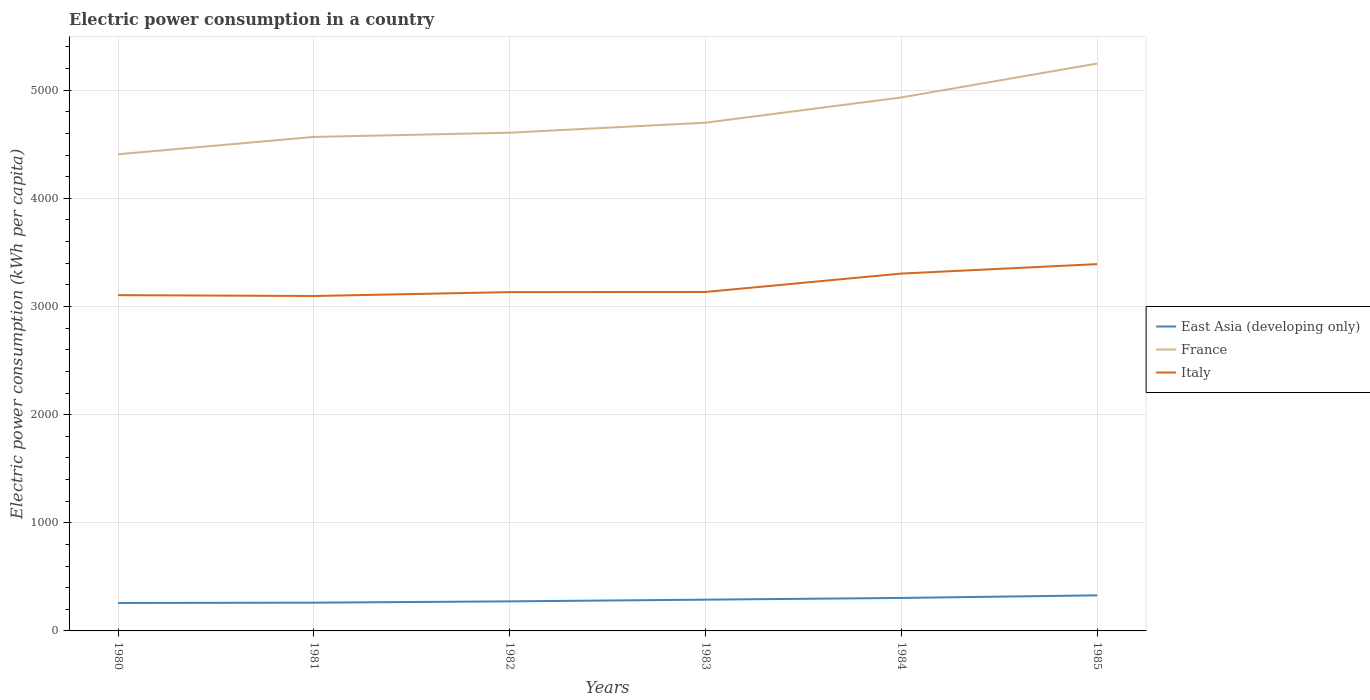Does the line corresponding to East Asia (developing only) intersect with the line corresponding to France?
Offer a very short reply. No. Is the number of lines equal to the number of legend labels?
Your answer should be very brief. Yes. Across all years, what is the maximum electric power consumption in in Italy?
Keep it short and to the point. 3096.93. In which year was the electric power consumption in in France maximum?
Your answer should be very brief. 1980. What is the total electric power consumption in in East Asia (developing only) in the graph?
Your answer should be very brief. -55.56. What is the difference between the highest and the second highest electric power consumption in in East Asia (developing only)?
Provide a succinct answer. 70.57. What is the difference between the highest and the lowest electric power consumption in in East Asia (developing only)?
Offer a terse response. 3. Is the electric power consumption in in East Asia (developing only) strictly greater than the electric power consumption in in France over the years?
Offer a very short reply. Yes. How many lines are there?
Your response must be concise. 3. Are the values on the major ticks of Y-axis written in scientific E-notation?
Offer a very short reply. No. Does the graph contain grids?
Keep it short and to the point. Yes. Where does the legend appear in the graph?
Keep it short and to the point. Center right. What is the title of the graph?
Make the answer very short. Electric power consumption in a country. Does "Uruguay" appear as one of the legend labels in the graph?
Make the answer very short. No. What is the label or title of the Y-axis?
Your answer should be very brief. Electric power consumption (kWh per capita). What is the Electric power consumption (kWh per capita) in East Asia (developing only) in 1980?
Ensure brevity in your answer.  258.4. What is the Electric power consumption (kWh per capita) of France in 1980?
Keep it short and to the point. 4407.65. What is the Electric power consumption (kWh per capita) in Italy in 1980?
Keep it short and to the point. 3104.85. What is the Electric power consumption (kWh per capita) of East Asia (developing only) in 1981?
Provide a short and direct response. 261.33. What is the Electric power consumption (kWh per capita) of France in 1981?
Keep it short and to the point. 4567.75. What is the Electric power consumption (kWh per capita) in Italy in 1981?
Your answer should be compact. 3096.93. What is the Electric power consumption (kWh per capita) of East Asia (developing only) in 1982?
Give a very brief answer. 273.41. What is the Electric power consumption (kWh per capita) of France in 1982?
Provide a short and direct response. 4606.91. What is the Electric power consumption (kWh per capita) in Italy in 1982?
Make the answer very short. 3132.77. What is the Electric power consumption (kWh per capita) in East Asia (developing only) in 1983?
Keep it short and to the point. 289.15. What is the Electric power consumption (kWh per capita) in France in 1983?
Your response must be concise. 4699.51. What is the Electric power consumption (kWh per capita) of Italy in 1983?
Your answer should be very brief. 3134.39. What is the Electric power consumption (kWh per capita) in East Asia (developing only) in 1984?
Offer a terse response. 305.06. What is the Electric power consumption (kWh per capita) of France in 1984?
Your response must be concise. 4933.01. What is the Electric power consumption (kWh per capita) in Italy in 1984?
Provide a succinct answer. 3304.33. What is the Electric power consumption (kWh per capita) in East Asia (developing only) in 1985?
Keep it short and to the point. 328.97. What is the Electric power consumption (kWh per capita) in France in 1985?
Your answer should be very brief. 5246.4. What is the Electric power consumption (kWh per capita) in Italy in 1985?
Give a very brief answer. 3391.67. Across all years, what is the maximum Electric power consumption (kWh per capita) of East Asia (developing only)?
Keep it short and to the point. 328.97. Across all years, what is the maximum Electric power consumption (kWh per capita) in France?
Ensure brevity in your answer.  5246.4. Across all years, what is the maximum Electric power consumption (kWh per capita) in Italy?
Give a very brief answer. 3391.67. Across all years, what is the minimum Electric power consumption (kWh per capita) of East Asia (developing only)?
Provide a short and direct response. 258.4. Across all years, what is the minimum Electric power consumption (kWh per capita) of France?
Your answer should be compact. 4407.65. Across all years, what is the minimum Electric power consumption (kWh per capita) of Italy?
Your answer should be compact. 3096.93. What is the total Electric power consumption (kWh per capita) of East Asia (developing only) in the graph?
Offer a very short reply. 1716.32. What is the total Electric power consumption (kWh per capita) of France in the graph?
Your response must be concise. 2.85e+04. What is the total Electric power consumption (kWh per capita) in Italy in the graph?
Provide a succinct answer. 1.92e+04. What is the difference between the Electric power consumption (kWh per capita) of East Asia (developing only) in 1980 and that in 1981?
Keep it short and to the point. -2.94. What is the difference between the Electric power consumption (kWh per capita) in France in 1980 and that in 1981?
Make the answer very short. -160.09. What is the difference between the Electric power consumption (kWh per capita) in Italy in 1980 and that in 1981?
Offer a terse response. 7.92. What is the difference between the Electric power consumption (kWh per capita) in East Asia (developing only) in 1980 and that in 1982?
Give a very brief answer. -15.01. What is the difference between the Electric power consumption (kWh per capita) of France in 1980 and that in 1982?
Make the answer very short. -199.25. What is the difference between the Electric power consumption (kWh per capita) in Italy in 1980 and that in 1982?
Ensure brevity in your answer.  -27.92. What is the difference between the Electric power consumption (kWh per capita) of East Asia (developing only) in 1980 and that in 1983?
Offer a very short reply. -30.75. What is the difference between the Electric power consumption (kWh per capita) of France in 1980 and that in 1983?
Offer a very short reply. -291.86. What is the difference between the Electric power consumption (kWh per capita) in Italy in 1980 and that in 1983?
Ensure brevity in your answer.  -29.54. What is the difference between the Electric power consumption (kWh per capita) of East Asia (developing only) in 1980 and that in 1984?
Keep it short and to the point. -46.66. What is the difference between the Electric power consumption (kWh per capita) of France in 1980 and that in 1984?
Your answer should be compact. -525.36. What is the difference between the Electric power consumption (kWh per capita) in Italy in 1980 and that in 1984?
Offer a terse response. -199.47. What is the difference between the Electric power consumption (kWh per capita) in East Asia (developing only) in 1980 and that in 1985?
Make the answer very short. -70.57. What is the difference between the Electric power consumption (kWh per capita) in France in 1980 and that in 1985?
Your answer should be very brief. -838.75. What is the difference between the Electric power consumption (kWh per capita) in Italy in 1980 and that in 1985?
Ensure brevity in your answer.  -286.81. What is the difference between the Electric power consumption (kWh per capita) of East Asia (developing only) in 1981 and that in 1982?
Your answer should be very brief. -12.08. What is the difference between the Electric power consumption (kWh per capita) of France in 1981 and that in 1982?
Offer a very short reply. -39.16. What is the difference between the Electric power consumption (kWh per capita) of Italy in 1981 and that in 1982?
Offer a very short reply. -35.84. What is the difference between the Electric power consumption (kWh per capita) of East Asia (developing only) in 1981 and that in 1983?
Make the answer very short. -27.82. What is the difference between the Electric power consumption (kWh per capita) of France in 1981 and that in 1983?
Provide a succinct answer. -131.76. What is the difference between the Electric power consumption (kWh per capita) in Italy in 1981 and that in 1983?
Provide a succinct answer. -37.46. What is the difference between the Electric power consumption (kWh per capita) in East Asia (developing only) in 1981 and that in 1984?
Your answer should be compact. -43.72. What is the difference between the Electric power consumption (kWh per capita) in France in 1981 and that in 1984?
Offer a very short reply. -365.26. What is the difference between the Electric power consumption (kWh per capita) in Italy in 1981 and that in 1984?
Give a very brief answer. -207.39. What is the difference between the Electric power consumption (kWh per capita) in East Asia (developing only) in 1981 and that in 1985?
Your answer should be very brief. -67.63. What is the difference between the Electric power consumption (kWh per capita) of France in 1981 and that in 1985?
Provide a succinct answer. -678.65. What is the difference between the Electric power consumption (kWh per capita) in Italy in 1981 and that in 1985?
Offer a terse response. -294.73. What is the difference between the Electric power consumption (kWh per capita) of East Asia (developing only) in 1982 and that in 1983?
Offer a very short reply. -15.74. What is the difference between the Electric power consumption (kWh per capita) in France in 1982 and that in 1983?
Ensure brevity in your answer.  -92.6. What is the difference between the Electric power consumption (kWh per capita) of Italy in 1982 and that in 1983?
Give a very brief answer. -1.62. What is the difference between the Electric power consumption (kWh per capita) in East Asia (developing only) in 1982 and that in 1984?
Give a very brief answer. -31.65. What is the difference between the Electric power consumption (kWh per capita) of France in 1982 and that in 1984?
Offer a terse response. -326.1. What is the difference between the Electric power consumption (kWh per capita) of Italy in 1982 and that in 1984?
Provide a short and direct response. -171.56. What is the difference between the Electric power consumption (kWh per capita) in East Asia (developing only) in 1982 and that in 1985?
Offer a very short reply. -55.56. What is the difference between the Electric power consumption (kWh per capita) of France in 1982 and that in 1985?
Your response must be concise. -639.49. What is the difference between the Electric power consumption (kWh per capita) in Italy in 1982 and that in 1985?
Offer a very short reply. -258.9. What is the difference between the Electric power consumption (kWh per capita) in East Asia (developing only) in 1983 and that in 1984?
Provide a succinct answer. -15.91. What is the difference between the Electric power consumption (kWh per capita) of France in 1983 and that in 1984?
Offer a terse response. -233.5. What is the difference between the Electric power consumption (kWh per capita) of Italy in 1983 and that in 1984?
Make the answer very short. -169.94. What is the difference between the Electric power consumption (kWh per capita) in East Asia (developing only) in 1983 and that in 1985?
Your response must be concise. -39.82. What is the difference between the Electric power consumption (kWh per capita) of France in 1983 and that in 1985?
Keep it short and to the point. -546.89. What is the difference between the Electric power consumption (kWh per capita) in Italy in 1983 and that in 1985?
Offer a terse response. -257.28. What is the difference between the Electric power consumption (kWh per capita) of East Asia (developing only) in 1984 and that in 1985?
Your answer should be very brief. -23.91. What is the difference between the Electric power consumption (kWh per capita) of France in 1984 and that in 1985?
Your answer should be compact. -313.39. What is the difference between the Electric power consumption (kWh per capita) of Italy in 1984 and that in 1985?
Your response must be concise. -87.34. What is the difference between the Electric power consumption (kWh per capita) of East Asia (developing only) in 1980 and the Electric power consumption (kWh per capita) of France in 1981?
Provide a succinct answer. -4309.35. What is the difference between the Electric power consumption (kWh per capita) in East Asia (developing only) in 1980 and the Electric power consumption (kWh per capita) in Italy in 1981?
Your answer should be compact. -2838.54. What is the difference between the Electric power consumption (kWh per capita) of France in 1980 and the Electric power consumption (kWh per capita) of Italy in 1981?
Offer a terse response. 1310.72. What is the difference between the Electric power consumption (kWh per capita) in East Asia (developing only) in 1980 and the Electric power consumption (kWh per capita) in France in 1982?
Ensure brevity in your answer.  -4348.51. What is the difference between the Electric power consumption (kWh per capita) of East Asia (developing only) in 1980 and the Electric power consumption (kWh per capita) of Italy in 1982?
Your answer should be compact. -2874.37. What is the difference between the Electric power consumption (kWh per capita) in France in 1980 and the Electric power consumption (kWh per capita) in Italy in 1982?
Give a very brief answer. 1274.88. What is the difference between the Electric power consumption (kWh per capita) of East Asia (developing only) in 1980 and the Electric power consumption (kWh per capita) of France in 1983?
Your answer should be very brief. -4441.11. What is the difference between the Electric power consumption (kWh per capita) in East Asia (developing only) in 1980 and the Electric power consumption (kWh per capita) in Italy in 1983?
Keep it short and to the point. -2875.99. What is the difference between the Electric power consumption (kWh per capita) in France in 1980 and the Electric power consumption (kWh per capita) in Italy in 1983?
Your answer should be compact. 1273.26. What is the difference between the Electric power consumption (kWh per capita) in East Asia (developing only) in 1980 and the Electric power consumption (kWh per capita) in France in 1984?
Provide a succinct answer. -4674.61. What is the difference between the Electric power consumption (kWh per capita) of East Asia (developing only) in 1980 and the Electric power consumption (kWh per capita) of Italy in 1984?
Ensure brevity in your answer.  -3045.93. What is the difference between the Electric power consumption (kWh per capita) of France in 1980 and the Electric power consumption (kWh per capita) of Italy in 1984?
Your response must be concise. 1103.33. What is the difference between the Electric power consumption (kWh per capita) of East Asia (developing only) in 1980 and the Electric power consumption (kWh per capita) of France in 1985?
Make the answer very short. -4988. What is the difference between the Electric power consumption (kWh per capita) of East Asia (developing only) in 1980 and the Electric power consumption (kWh per capita) of Italy in 1985?
Your answer should be compact. -3133.27. What is the difference between the Electric power consumption (kWh per capita) of France in 1980 and the Electric power consumption (kWh per capita) of Italy in 1985?
Offer a terse response. 1015.98. What is the difference between the Electric power consumption (kWh per capita) of East Asia (developing only) in 1981 and the Electric power consumption (kWh per capita) of France in 1982?
Your answer should be compact. -4345.57. What is the difference between the Electric power consumption (kWh per capita) in East Asia (developing only) in 1981 and the Electric power consumption (kWh per capita) in Italy in 1982?
Provide a short and direct response. -2871.44. What is the difference between the Electric power consumption (kWh per capita) in France in 1981 and the Electric power consumption (kWh per capita) in Italy in 1982?
Offer a very short reply. 1434.98. What is the difference between the Electric power consumption (kWh per capita) in East Asia (developing only) in 1981 and the Electric power consumption (kWh per capita) in France in 1983?
Keep it short and to the point. -4438.18. What is the difference between the Electric power consumption (kWh per capita) in East Asia (developing only) in 1981 and the Electric power consumption (kWh per capita) in Italy in 1983?
Your answer should be compact. -2873.06. What is the difference between the Electric power consumption (kWh per capita) of France in 1981 and the Electric power consumption (kWh per capita) of Italy in 1983?
Keep it short and to the point. 1433.36. What is the difference between the Electric power consumption (kWh per capita) of East Asia (developing only) in 1981 and the Electric power consumption (kWh per capita) of France in 1984?
Provide a succinct answer. -4671.68. What is the difference between the Electric power consumption (kWh per capita) of East Asia (developing only) in 1981 and the Electric power consumption (kWh per capita) of Italy in 1984?
Ensure brevity in your answer.  -3042.99. What is the difference between the Electric power consumption (kWh per capita) in France in 1981 and the Electric power consumption (kWh per capita) in Italy in 1984?
Offer a terse response. 1263.42. What is the difference between the Electric power consumption (kWh per capita) in East Asia (developing only) in 1981 and the Electric power consumption (kWh per capita) in France in 1985?
Offer a very short reply. -4985.07. What is the difference between the Electric power consumption (kWh per capita) in East Asia (developing only) in 1981 and the Electric power consumption (kWh per capita) in Italy in 1985?
Provide a short and direct response. -3130.34. What is the difference between the Electric power consumption (kWh per capita) of France in 1981 and the Electric power consumption (kWh per capita) of Italy in 1985?
Provide a short and direct response. 1176.08. What is the difference between the Electric power consumption (kWh per capita) of East Asia (developing only) in 1982 and the Electric power consumption (kWh per capita) of France in 1983?
Make the answer very short. -4426.1. What is the difference between the Electric power consumption (kWh per capita) in East Asia (developing only) in 1982 and the Electric power consumption (kWh per capita) in Italy in 1983?
Offer a terse response. -2860.98. What is the difference between the Electric power consumption (kWh per capita) in France in 1982 and the Electric power consumption (kWh per capita) in Italy in 1983?
Your response must be concise. 1472.52. What is the difference between the Electric power consumption (kWh per capita) in East Asia (developing only) in 1982 and the Electric power consumption (kWh per capita) in France in 1984?
Keep it short and to the point. -4659.6. What is the difference between the Electric power consumption (kWh per capita) of East Asia (developing only) in 1982 and the Electric power consumption (kWh per capita) of Italy in 1984?
Your answer should be very brief. -3030.92. What is the difference between the Electric power consumption (kWh per capita) in France in 1982 and the Electric power consumption (kWh per capita) in Italy in 1984?
Give a very brief answer. 1302.58. What is the difference between the Electric power consumption (kWh per capita) in East Asia (developing only) in 1982 and the Electric power consumption (kWh per capita) in France in 1985?
Offer a terse response. -4972.99. What is the difference between the Electric power consumption (kWh per capita) of East Asia (developing only) in 1982 and the Electric power consumption (kWh per capita) of Italy in 1985?
Ensure brevity in your answer.  -3118.26. What is the difference between the Electric power consumption (kWh per capita) in France in 1982 and the Electric power consumption (kWh per capita) in Italy in 1985?
Your response must be concise. 1215.24. What is the difference between the Electric power consumption (kWh per capita) in East Asia (developing only) in 1983 and the Electric power consumption (kWh per capita) in France in 1984?
Provide a succinct answer. -4643.86. What is the difference between the Electric power consumption (kWh per capita) in East Asia (developing only) in 1983 and the Electric power consumption (kWh per capita) in Italy in 1984?
Ensure brevity in your answer.  -3015.18. What is the difference between the Electric power consumption (kWh per capita) in France in 1983 and the Electric power consumption (kWh per capita) in Italy in 1984?
Provide a succinct answer. 1395.18. What is the difference between the Electric power consumption (kWh per capita) of East Asia (developing only) in 1983 and the Electric power consumption (kWh per capita) of France in 1985?
Make the answer very short. -4957.25. What is the difference between the Electric power consumption (kWh per capita) in East Asia (developing only) in 1983 and the Electric power consumption (kWh per capita) in Italy in 1985?
Make the answer very short. -3102.52. What is the difference between the Electric power consumption (kWh per capita) of France in 1983 and the Electric power consumption (kWh per capita) of Italy in 1985?
Offer a terse response. 1307.84. What is the difference between the Electric power consumption (kWh per capita) in East Asia (developing only) in 1984 and the Electric power consumption (kWh per capita) in France in 1985?
Offer a very short reply. -4941.34. What is the difference between the Electric power consumption (kWh per capita) of East Asia (developing only) in 1984 and the Electric power consumption (kWh per capita) of Italy in 1985?
Keep it short and to the point. -3086.61. What is the difference between the Electric power consumption (kWh per capita) of France in 1984 and the Electric power consumption (kWh per capita) of Italy in 1985?
Your answer should be very brief. 1541.34. What is the average Electric power consumption (kWh per capita) in East Asia (developing only) per year?
Keep it short and to the point. 286.05. What is the average Electric power consumption (kWh per capita) of France per year?
Give a very brief answer. 4743.54. What is the average Electric power consumption (kWh per capita) of Italy per year?
Offer a terse response. 3194.16. In the year 1980, what is the difference between the Electric power consumption (kWh per capita) of East Asia (developing only) and Electric power consumption (kWh per capita) of France?
Keep it short and to the point. -4149.25. In the year 1980, what is the difference between the Electric power consumption (kWh per capita) in East Asia (developing only) and Electric power consumption (kWh per capita) in Italy?
Your response must be concise. -2846.46. In the year 1980, what is the difference between the Electric power consumption (kWh per capita) in France and Electric power consumption (kWh per capita) in Italy?
Your response must be concise. 1302.8. In the year 1981, what is the difference between the Electric power consumption (kWh per capita) of East Asia (developing only) and Electric power consumption (kWh per capita) of France?
Make the answer very short. -4306.41. In the year 1981, what is the difference between the Electric power consumption (kWh per capita) in East Asia (developing only) and Electric power consumption (kWh per capita) in Italy?
Keep it short and to the point. -2835.6. In the year 1981, what is the difference between the Electric power consumption (kWh per capita) in France and Electric power consumption (kWh per capita) in Italy?
Your answer should be compact. 1470.81. In the year 1982, what is the difference between the Electric power consumption (kWh per capita) of East Asia (developing only) and Electric power consumption (kWh per capita) of France?
Your answer should be very brief. -4333.5. In the year 1982, what is the difference between the Electric power consumption (kWh per capita) of East Asia (developing only) and Electric power consumption (kWh per capita) of Italy?
Provide a short and direct response. -2859.36. In the year 1982, what is the difference between the Electric power consumption (kWh per capita) in France and Electric power consumption (kWh per capita) in Italy?
Provide a short and direct response. 1474.14. In the year 1983, what is the difference between the Electric power consumption (kWh per capita) of East Asia (developing only) and Electric power consumption (kWh per capita) of France?
Your response must be concise. -4410.36. In the year 1983, what is the difference between the Electric power consumption (kWh per capita) in East Asia (developing only) and Electric power consumption (kWh per capita) in Italy?
Offer a very short reply. -2845.24. In the year 1983, what is the difference between the Electric power consumption (kWh per capita) in France and Electric power consumption (kWh per capita) in Italy?
Your answer should be compact. 1565.12. In the year 1984, what is the difference between the Electric power consumption (kWh per capita) in East Asia (developing only) and Electric power consumption (kWh per capita) in France?
Give a very brief answer. -4627.95. In the year 1984, what is the difference between the Electric power consumption (kWh per capita) in East Asia (developing only) and Electric power consumption (kWh per capita) in Italy?
Your answer should be compact. -2999.27. In the year 1984, what is the difference between the Electric power consumption (kWh per capita) of France and Electric power consumption (kWh per capita) of Italy?
Give a very brief answer. 1628.68. In the year 1985, what is the difference between the Electric power consumption (kWh per capita) of East Asia (developing only) and Electric power consumption (kWh per capita) of France?
Your answer should be very brief. -4917.44. In the year 1985, what is the difference between the Electric power consumption (kWh per capita) of East Asia (developing only) and Electric power consumption (kWh per capita) of Italy?
Provide a short and direct response. -3062.7. In the year 1985, what is the difference between the Electric power consumption (kWh per capita) in France and Electric power consumption (kWh per capita) in Italy?
Offer a very short reply. 1854.73. What is the ratio of the Electric power consumption (kWh per capita) of France in 1980 to that in 1981?
Give a very brief answer. 0.96. What is the ratio of the Electric power consumption (kWh per capita) of East Asia (developing only) in 1980 to that in 1982?
Your response must be concise. 0.95. What is the ratio of the Electric power consumption (kWh per capita) in France in 1980 to that in 1982?
Make the answer very short. 0.96. What is the ratio of the Electric power consumption (kWh per capita) in East Asia (developing only) in 1980 to that in 1983?
Offer a very short reply. 0.89. What is the ratio of the Electric power consumption (kWh per capita) in France in 1980 to that in 1983?
Make the answer very short. 0.94. What is the ratio of the Electric power consumption (kWh per capita) of Italy in 1980 to that in 1983?
Your answer should be very brief. 0.99. What is the ratio of the Electric power consumption (kWh per capita) of East Asia (developing only) in 1980 to that in 1984?
Make the answer very short. 0.85. What is the ratio of the Electric power consumption (kWh per capita) in France in 1980 to that in 1984?
Ensure brevity in your answer.  0.89. What is the ratio of the Electric power consumption (kWh per capita) of Italy in 1980 to that in 1984?
Your response must be concise. 0.94. What is the ratio of the Electric power consumption (kWh per capita) of East Asia (developing only) in 1980 to that in 1985?
Provide a succinct answer. 0.79. What is the ratio of the Electric power consumption (kWh per capita) of France in 1980 to that in 1985?
Offer a terse response. 0.84. What is the ratio of the Electric power consumption (kWh per capita) in Italy in 1980 to that in 1985?
Your answer should be very brief. 0.92. What is the ratio of the Electric power consumption (kWh per capita) of East Asia (developing only) in 1981 to that in 1982?
Offer a very short reply. 0.96. What is the ratio of the Electric power consumption (kWh per capita) in France in 1981 to that in 1982?
Your answer should be very brief. 0.99. What is the ratio of the Electric power consumption (kWh per capita) in Italy in 1981 to that in 1982?
Your answer should be very brief. 0.99. What is the ratio of the Electric power consumption (kWh per capita) in East Asia (developing only) in 1981 to that in 1983?
Provide a short and direct response. 0.9. What is the ratio of the Electric power consumption (kWh per capita) in France in 1981 to that in 1983?
Offer a very short reply. 0.97. What is the ratio of the Electric power consumption (kWh per capita) of Italy in 1981 to that in 1983?
Your answer should be very brief. 0.99. What is the ratio of the Electric power consumption (kWh per capita) in East Asia (developing only) in 1981 to that in 1984?
Offer a terse response. 0.86. What is the ratio of the Electric power consumption (kWh per capita) of France in 1981 to that in 1984?
Give a very brief answer. 0.93. What is the ratio of the Electric power consumption (kWh per capita) of Italy in 1981 to that in 1984?
Give a very brief answer. 0.94. What is the ratio of the Electric power consumption (kWh per capita) of East Asia (developing only) in 1981 to that in 1985?
Ensure brevity in your answer.  0.79. What is the ratio of the Electric power consumption (kWh per capita) of France in 1981 to that in 1985?
Give a very brief answer. 0.87. What is the ratio of the Electric power consumption (kWh per capita) of Italy in 1981 to that in 1985?
Provide a succinct answer. 0.91. What is the ratio of the Electric power consumption (kWh per capita) of East Asia (developing only) in 1982 to that in 1983?
Offer a terse response. 0.95. What is the ratio of the Electric power consumption (kWh per capita) in France in 1982 to that in 1983?
Provide a short and direct response. 0.98. What is the ratio of the Electric power consumption (kWh per capita) in Italy in 1982 to that in 1983?
Make the answer very short. 1. What is the ratio of the Electric power consumption (kWh per capita) in East Asia (developing only) in 1982 to that in 1984?
Give a very brief answer. 0.9. What is the ratio of the Electric power consumption (kWh per capita) in France in 1982 to that in 1984?
Offer a very short reply. 0.93. What is the ratio of the Electric power consumption (kWh per capita) in Italy in 1982 to that in 1984?
Make the answer very short. 0.95. What is the ratio of the Electric power consumption (kWh per capita) of East Asia (developing only) in 1982 to that in 1985?
Ensure brevity in your answer.  0.83. What is the ratio of the Electric power consumption (kWh per capita) of France in 1982 to that in 1985?
Your response must be concise. 0.88. What is the ratio of the Electric power consumption (kWh per capita) of Italy in 1982 to that in 1985?
Give a very brief answer. 0.92. What is the ratio of the Electric power consumption (kWh per capita) of East Asia (developing only) in 1983 to that in 1984?
Your answer should be very brief. 0.95. What is the ratio of the Electric power consumption (kWh per capita) in France in 1983 to that in 1984?
Make the answer very short. 0.95. What is the ratio of the Electric power consumption (kWh per capita) of Italy in 1983 to that in 1984?
Provide a succinct answer. 0.95. What is the ratio of the Electric power consumption (kWh per capita) in East Asia (developing only) in 1983 to that in 1985?
Make the answer very short. 0.88. What is the ratio of the Electric power consumption (kWh per capita) in France in 1983 to that in 1985?
Give a very brief answer. 0.9. What is the ratio of the Electric power consumption (kWh per capita) of Italy in 1983 to that in 1985?
Your answer should be compact. 0.92. What is the ratio of the Electric power consumption (kWh per capita) of East Asia (developing only) in 1984 to that in 1985?
Keep it short and to the point. 0.93. What is the ratio of the Electric power consumption (kWh per capita) of France in 1984 to that in 1985?
Make the answer very short. 0.94. What is the ratio of the Electric power consumption (kWh per capita) of Italy in 1984 to that in 1985?
Ensure brevity in your answer.  0.97. What is the difference between the highest and the second highest Electric power consumption (kWh per capita) in East Asia (developing only)?
Provide a succinct answer. 23.91. What is the difference between the highest and the second highest Electric power consumption (kWh per capita) in France?
Keep it short and to the point. 313.39. What is the difference between the highest and the second highest Electric power consumption (kWh per capita) in Italy?
Make the answer very short. 87.34. What is the difference between the highest and the lowest Electric power consumption (kWh per capita) in East Asia (developing only)?
Provide a short and direct response. 70.57. What is the difference between the highest and the lowest Electric power consumption (kWh per capita) in France?
Your answer should be very brief. 838.75. What is the difference between the highest and the lowest Electric power consumption (kWh per capita) in Italy?
Your response must be concise. 294.73. 